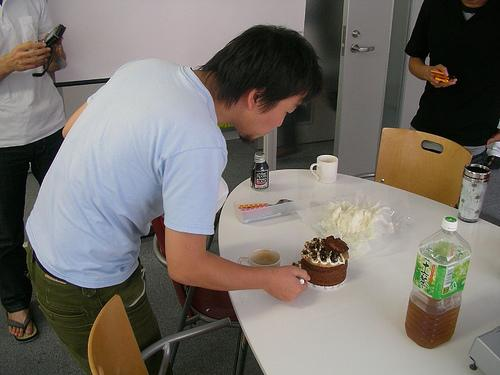About how much liquid is in the bottle with the green label?

Choices:
A) nine tenths
B) third
C) full
D) none third 